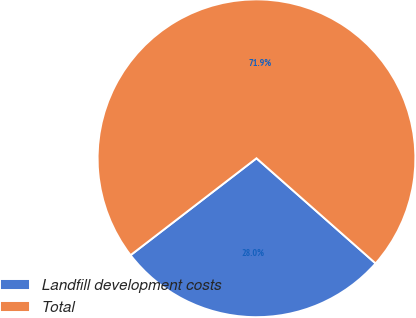Convert chart. <chart><loc_0><loc_0><loc_500><loc_500><pie_chart><fcel>Landfill development costs<fcel>Total<nl><fcel>28.05%<fcel>71.95%<nl></chart> 